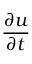Convert formula to latex. <formula><loc_0><loc_0><loc_500><loc_500>\frac { \partial u } { \partial t }</formula> 